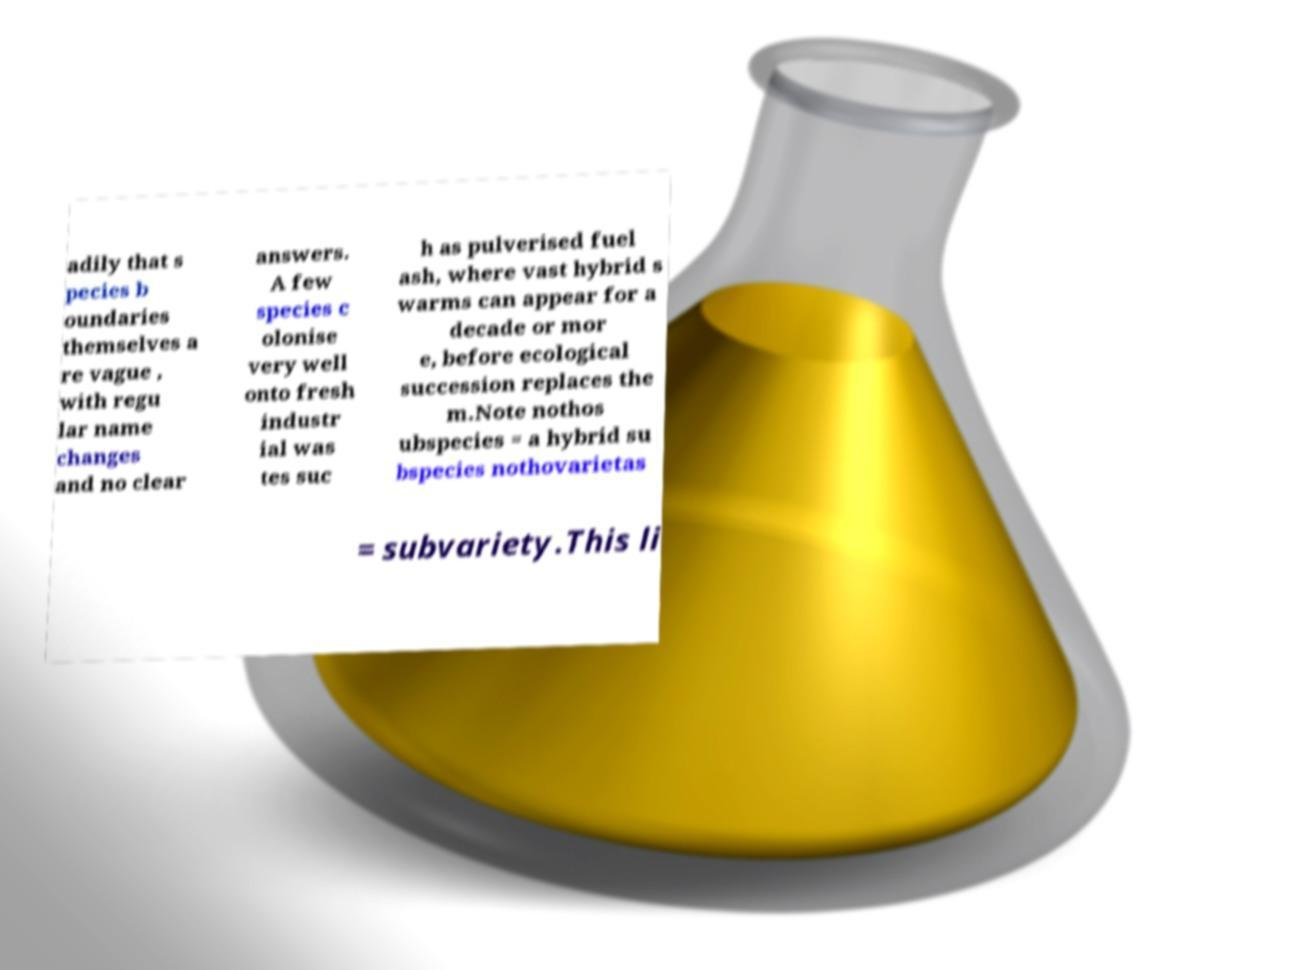What messages or text are displayed in this image? I need them in a readable, typed format. adily that s pecies b oundaries themselves a re vague , with regu lar name changes and no clear answers. A few species c olonise very well onto fresh industr ial was tes suc h as pulverised fuel ash, where vast hybrid s warms can appear for a decade or mor e, before ecological succession replaces the m.Note nothos ubspecies = a hybrid su bspecies nothovarietas = subvariety.This li 